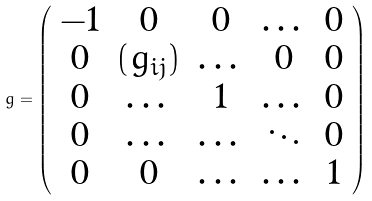<formula> <loc_0><loc_0><loc_500><loc_500>g = \left ( \begin{array} { c c c c c } - 1 & 0 & 0 & \dots & 0 \\ 0 & ( g _ { i j } ) & \dots & 0 & 0 \\ 0 & \dots & 1 & \dots & 0 \\ 0 & \dots & \dots & \ddots & 0 \\ 0 & 0 & \dots & \dots & 1 \\ \end{array} \right )</formula> 